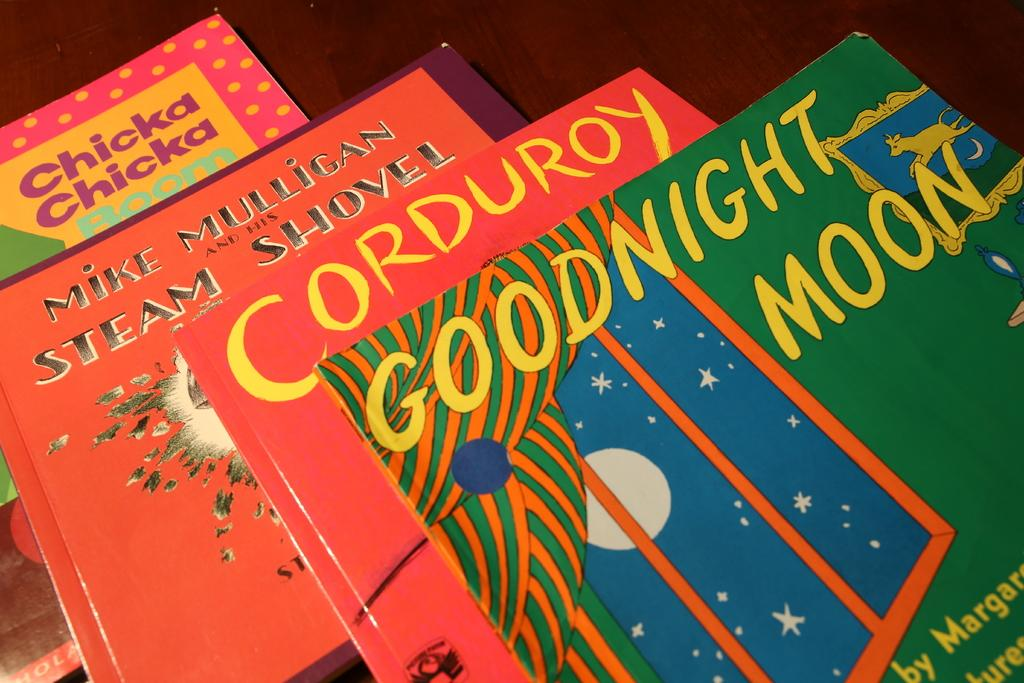Provide a one-sentence caption for the provided image. A pile of books with the top being called Goodnight Moon. 